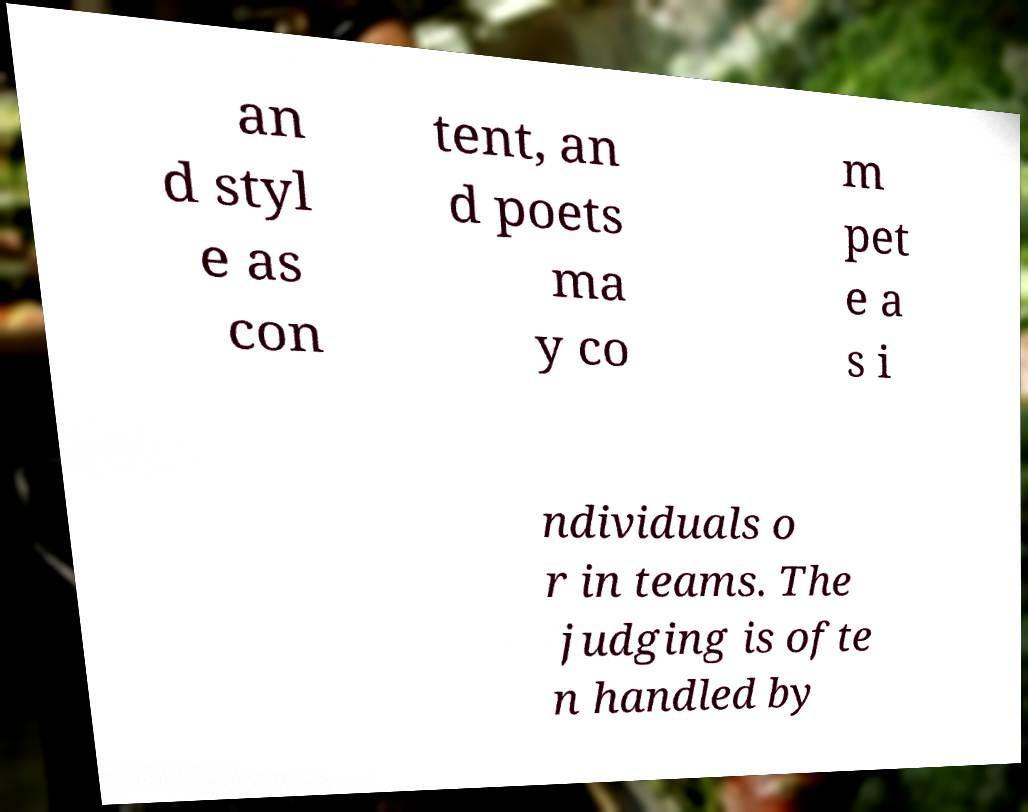What messages or text are displayed in this image? I need them in a readable, typed format. an d styl e as con tent, an d poets ma y co m pet e a s i ndividuals o r in teams. The judging is ofte n handled by 